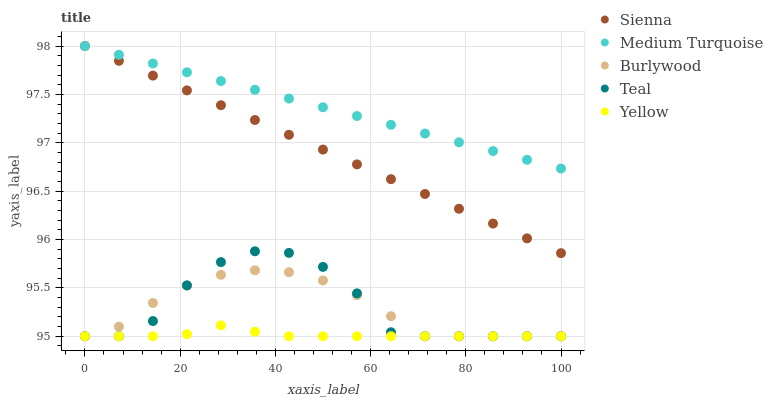Does Yellow have the minimum area under the curve?
Answer yes or no. Yes. Does Medium Turquoise have the maximum area under the curve?
Answer yes or no. Yes. Does Burlywood have the minimum area under the curve?
Answer yes or no. No. Does Burlywood have the maximum area under the curve?
Answer yes or no. No. Is Medium Turquoise the smoothest?
Answer yes or no. Yes. Is Teal the roughest?
Answer yes or no. Yes. Is Burlywood the smoothest?
Answer yes or no. No. Is Burlywood the roughest?
Answer yes or no. No. Does Burlywood have the lowest value?
Answer yes or no. Yes. Does Medium Turquoise have the lowest value?
Answer yes or no. No. Does Medium Turquoise have the highest value?
Answer yes or no. Yes. Does Burlywood have the highest value?
Answer yes or no. No. Is Teal less than Sienna?
Answer yes or no. Yes. Is Sienna greater than Yellow?
Answer yes or no. Yes. Does Yellow intersect Burlywood?
Answer yes or no. Yes. Is Yellow less than Burlywood?
Answer yes or no. No. Is Yellow greater than Burlywood?
Answer yes or no. No. Does Teal intersect Sienna?
Answer yes or no. No. 